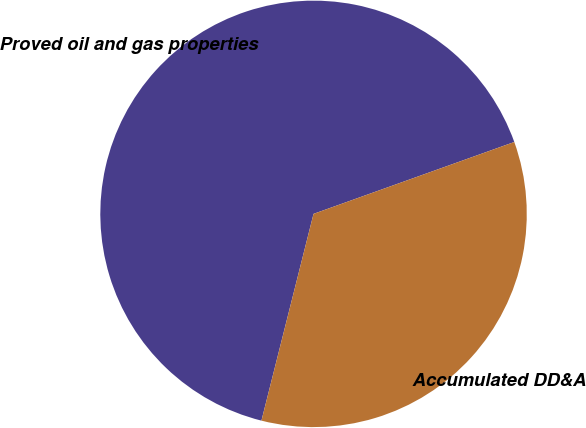<chart> <loc_0><loc_0><loc_500><loc_500><pie_chart><fcel>Proved oil and gas properties<fcel>Accumulated DD&A<nl><fcel>65.6%<fcel>34.4%<nl></chart> 